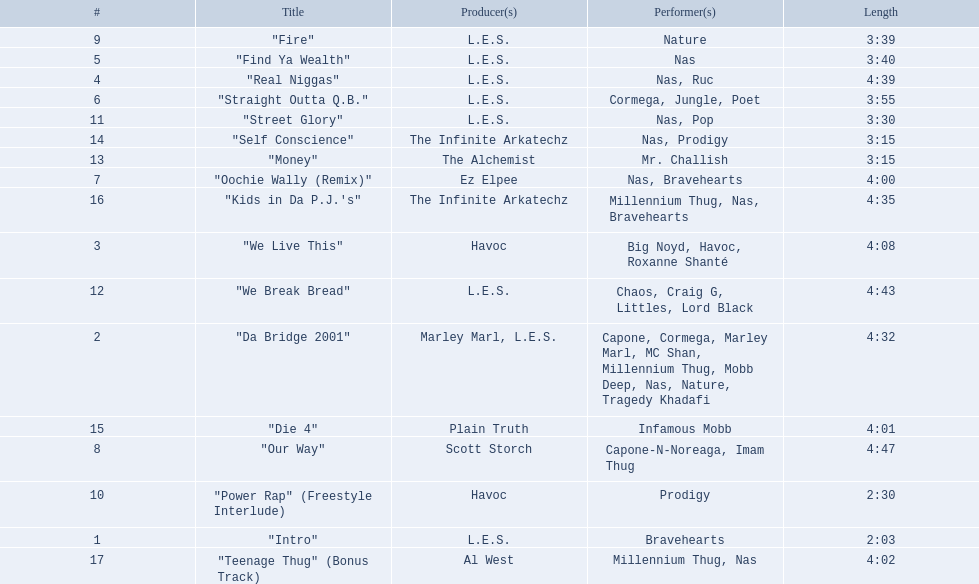What are all the songs on the album? "Intro", "Da Bridge 2001", "We Live This", "Real Niggas", "Find Ya Wealth", "Straight Outta Q.B.", "Oochie Wally (Remix)", "Our Way", "Fire", "Power Rap" (Freestyle Interlude), "Street Glory", "We Break Bread", "Money", "Self Conscience", "Die 4", "Kids in Da P.J.'s", "Teenage Thug" (Bonus Track). Which is the shortest? "Intro". How long is that song? 2:03. 